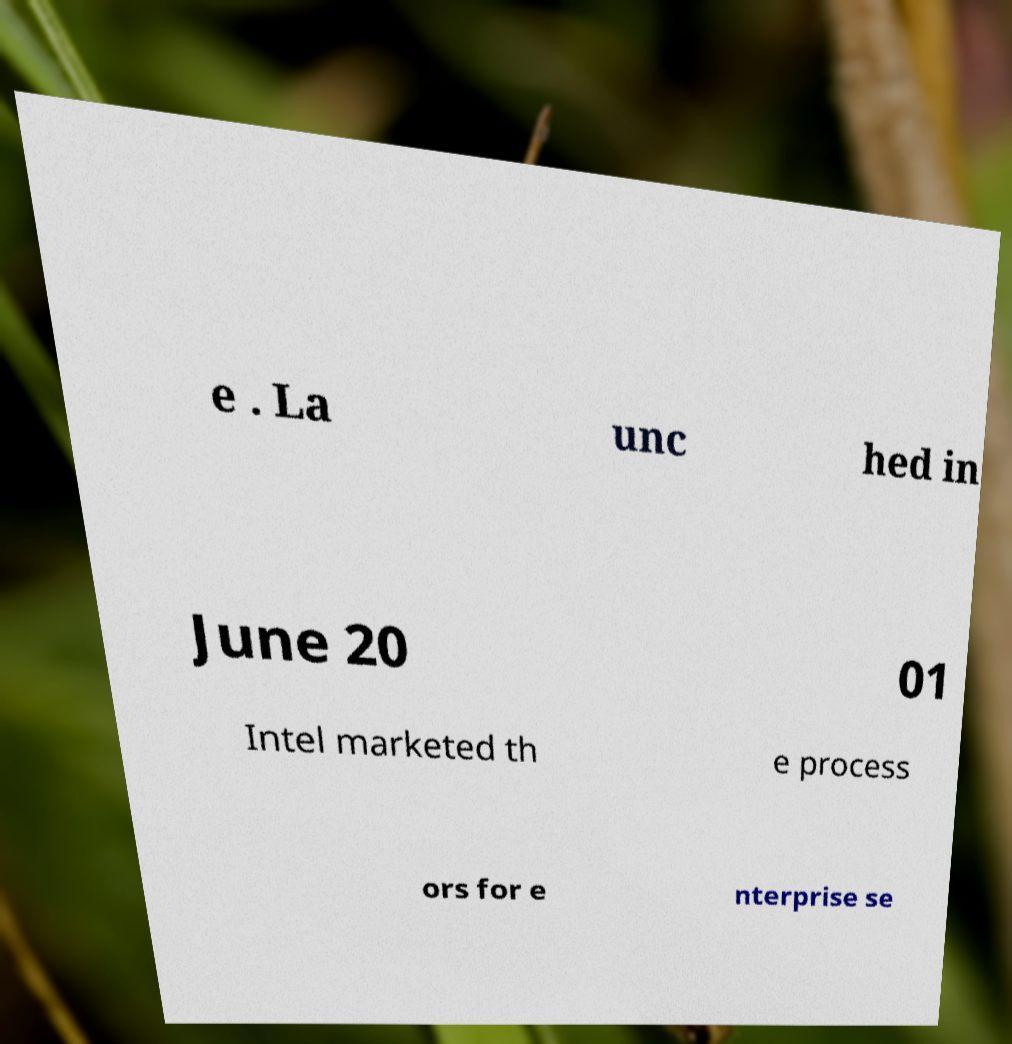There's text embedded in this image that I need extracted. Can you transcribe it verbatim? e . La unc hed in June 20 01 Intel marketed th e process ors for e nterprise se 